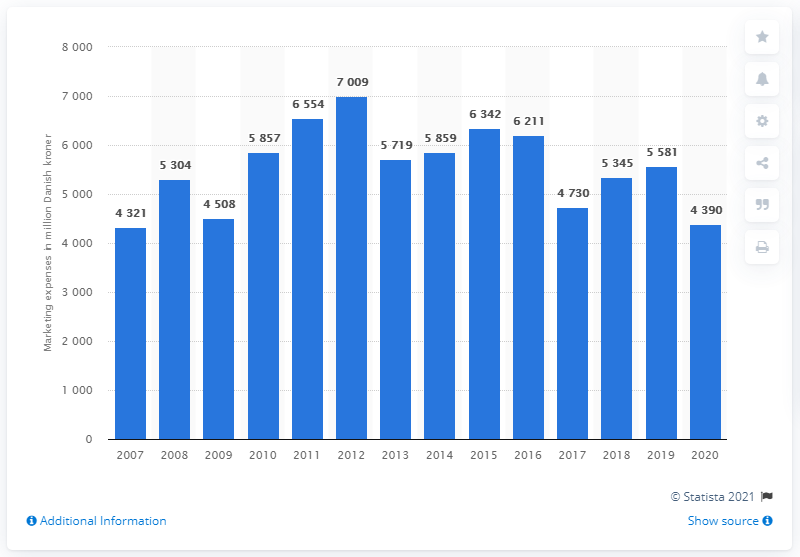Mention a couple of crucial points in this snapshot. In 2020, Carlsberg's marketing expenses totaled approximately 4,390. 